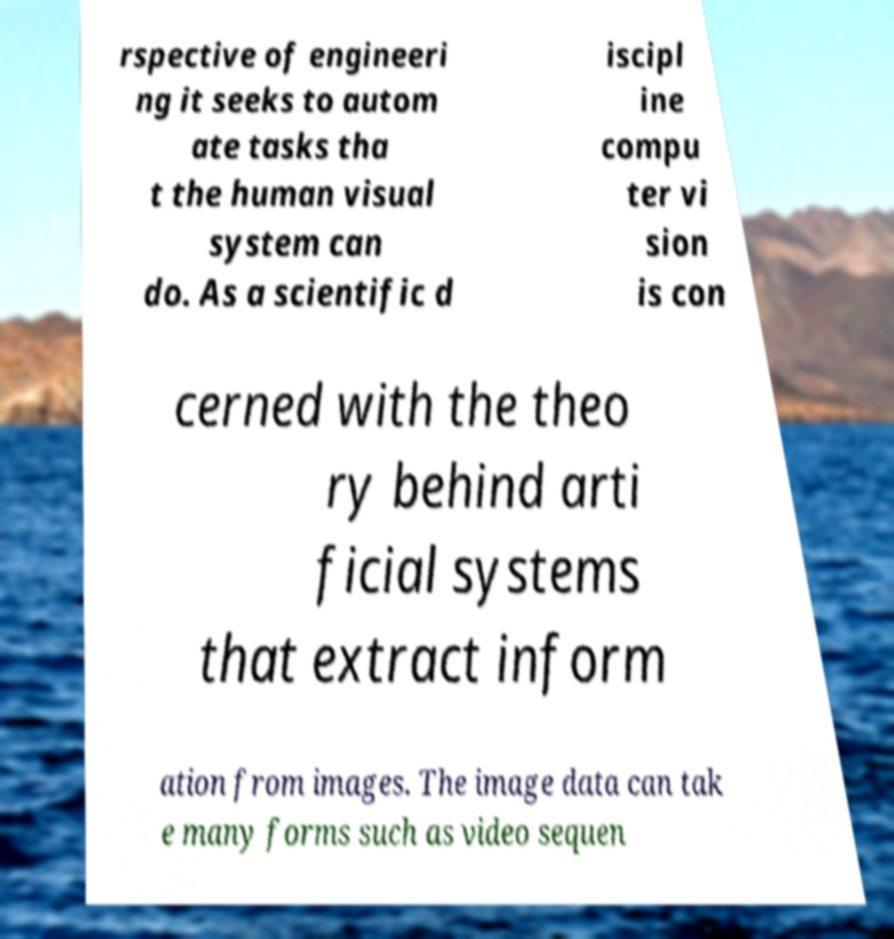Can you accurately transcribe the text from the provided image for me? rspective of engineeri ng it seeks to autom ate tasks tha t the human visual system can do. As a scientific d iscipl ine compu ter vi sion is con cerned with the theo ry behind arti ficial systems that extract inform ation from images. The image data can tak e many forms such as video sequen 